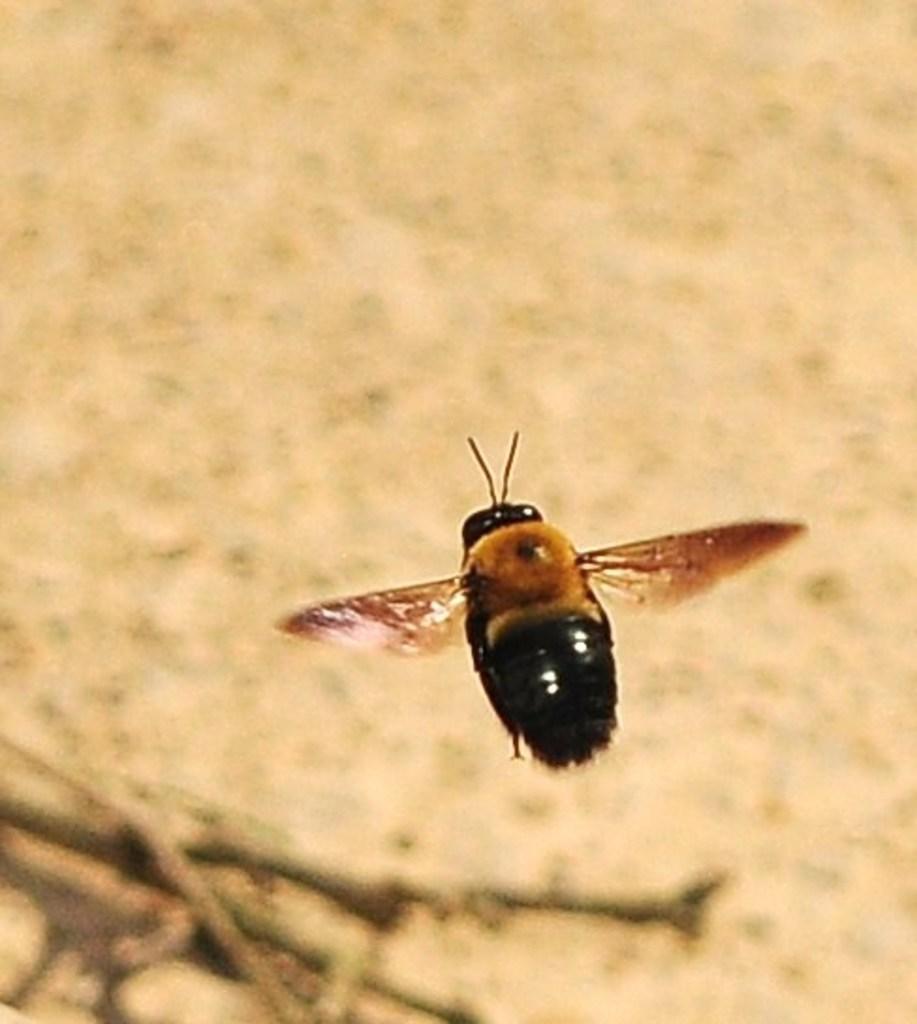Please provide a concise description of this image. In this picture we can see an insect and behind the insect there is the blurred background. 